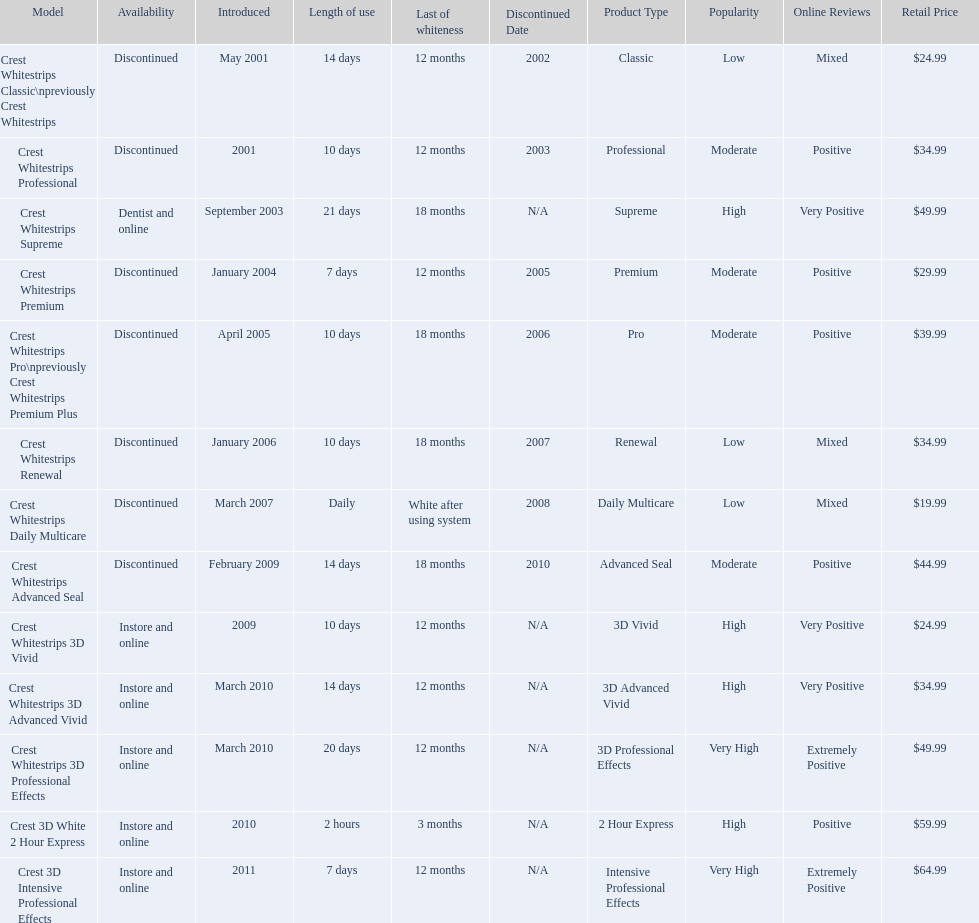Which of these products are discontinued? Crest Whitestrips Classic\npreviously Crest Whitestrips, Crest Whitestrips Professional, Crest Whitestrips Premium, Crest Whitestrips Pro\npreviously Crest Whitestrips Premium Plus, Crest Whitestrips Renewal, Crest Whitestrips Daily Multicare, Crest Whitestrips Advanced Seal. Which of these products have a 14 day length of use? Crest Whitestrips Classic\npreviously Crest Whitestrips, Crest Whitestrips Advanced Seal. Which of these products was introduced in 2009? Crest Whitestrips Advanced Seal. 